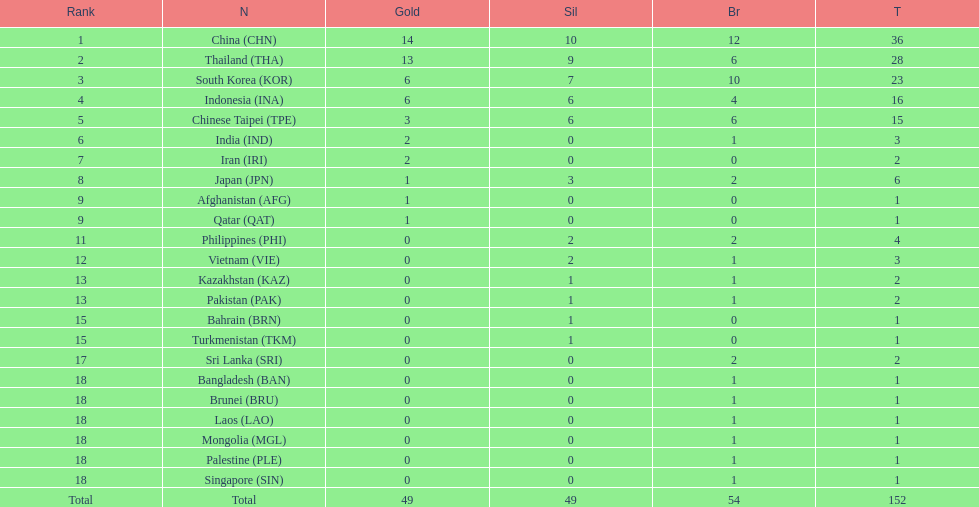How many countries received a medal in gold, silver, and bronze categories? 6. 